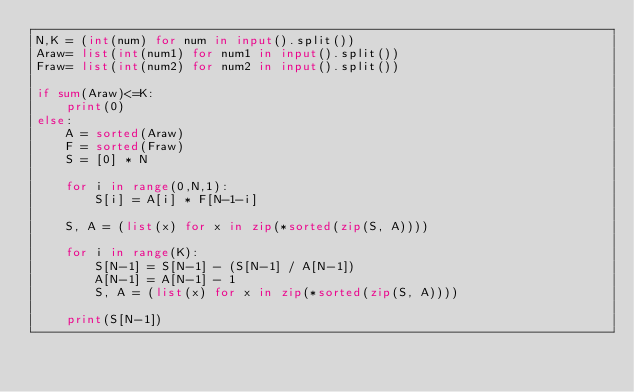<code> <loc_0><loc_0><loc_500><loc_500><_Python_>N,K = (int(num) for num in input().split())
Araw= list(int(num1) for num1 in input().split())
Fraw= list(int(num2) for num2 in input().split())

if sum(Araw)<=K:
    print(0)
else:
    A = sorted(Araw)
    F = sorted(Fraw)
    S = [0] * N

    for i in range(0,N,1):
        S[i] = A[i] * F[N-1-i]

    S, A = (list(x) for x in zip(*sorted(zip(S, A))))

    for i in range(K):
        S[N-1] = S[N-1] - (S[N-1] / A[N-1])
        A[N-1] = A[N-1] - 1
        S, A = (list(x) for x in zip(*sorted(zip(S, A))))
    
    print(S[N-1])
</code> 